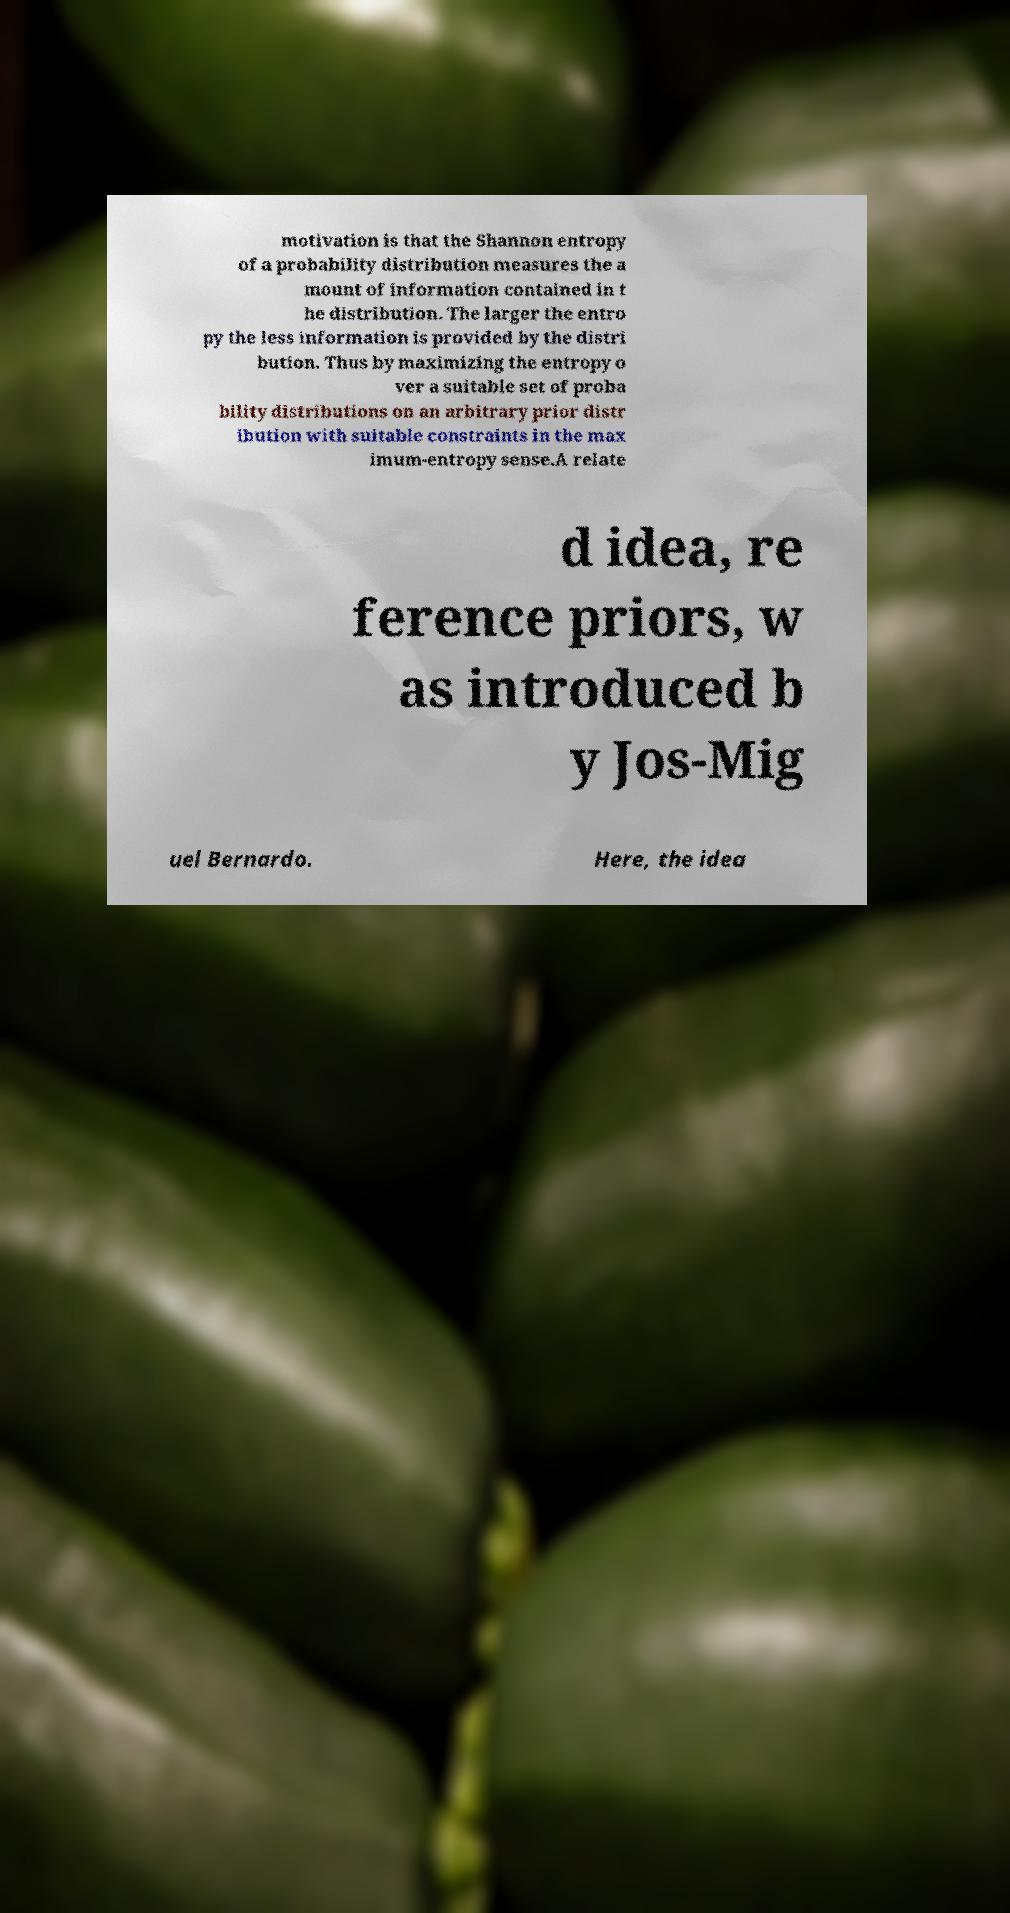Could you extract and type out the text from this image? motivation is that the Shannon entropy of a probability distribution measures the a mount of information contained in t he distribution. The larger the entro py the less information is provided by the distri bution. Thus by maximizing the entropy o ver a suitable set of proba bility distributions on an arbitrary prior distr ibution with suitable constraints in the max imum-entropy sense.A relate d idea, re ference priors, w as introduced b y Jos-Mig uel Bernardo. Here, the idea 